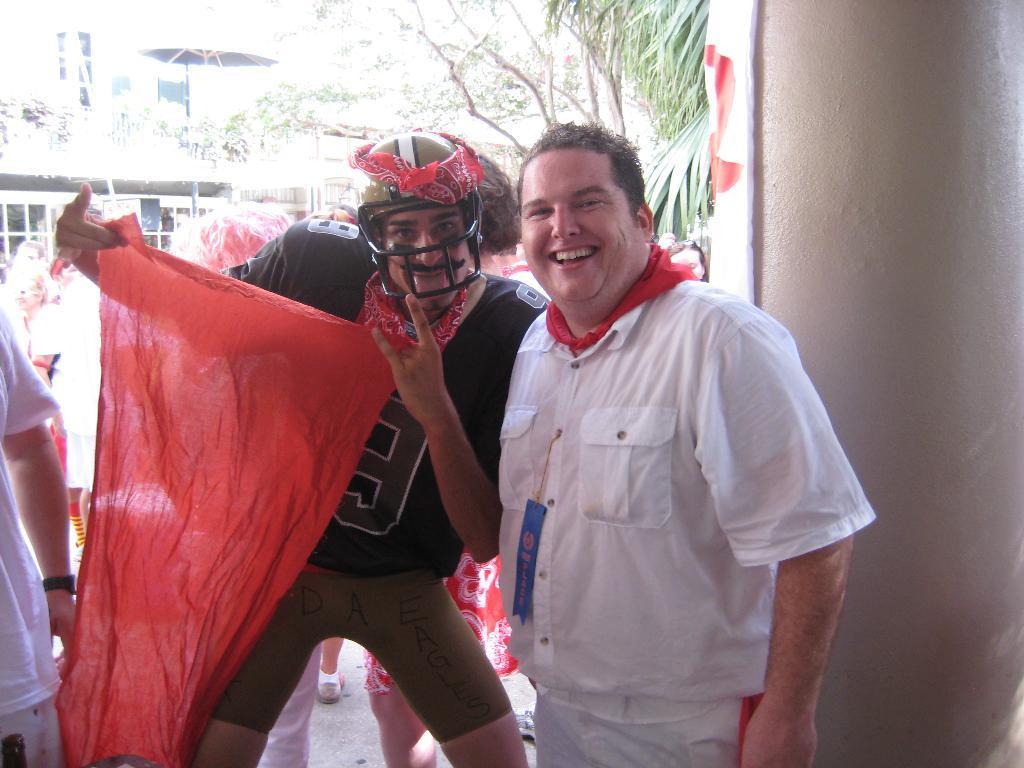Can you describe this image briefly? In the foreground of this image, there is a man in white dress and also another man holding a red color cloth and wearing a helmet. On the right, there is a white pillar. On the left, there is a person. In the background, there are persons, few trees and it seems like few buildings. 